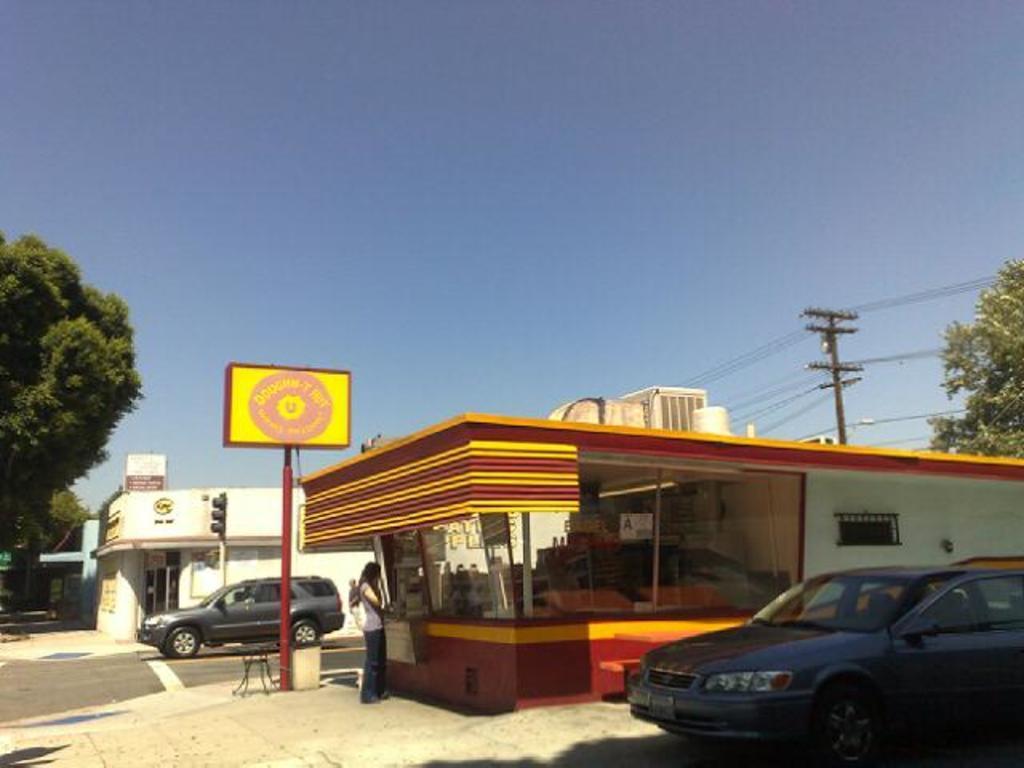Please provide a concise description of this image. In this picture we can see a person standing on the ground, table, name board, traffic signal, poles, vehicles on the road, buildings, trees, wires, some objects and in the background we can see the sky. 